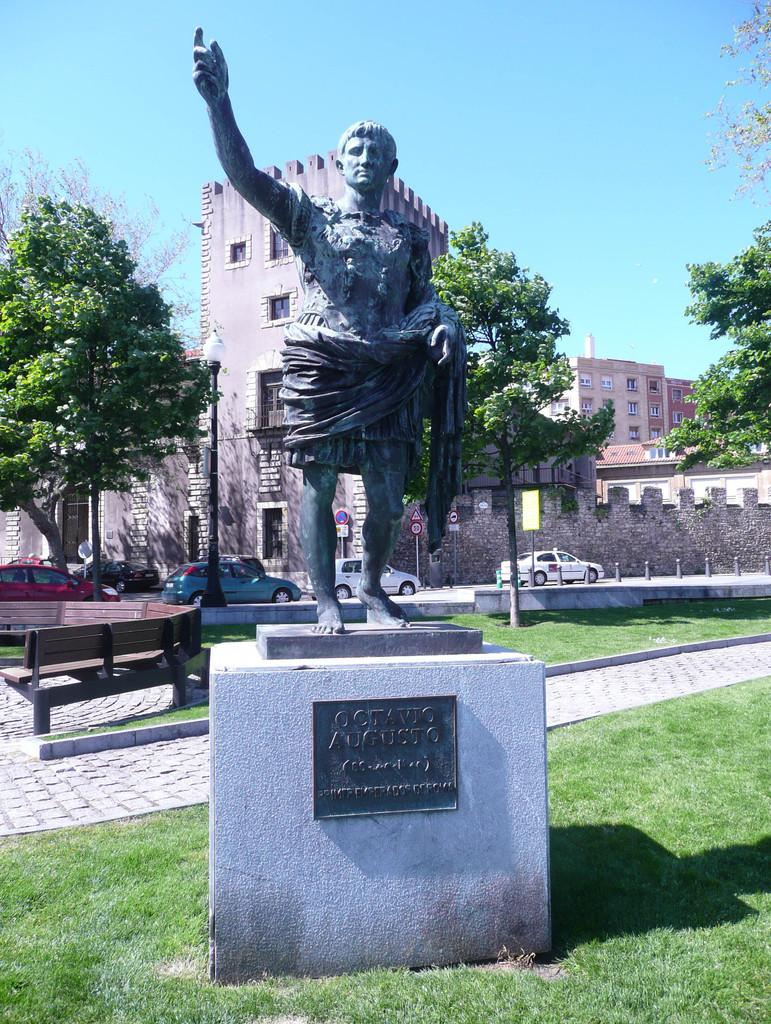What is the main subject in the center of the image? There is a statue in the center of the image. Where is the statue located? The statue is on the grass. What can be seen in the background of the image? In the background of the image, there are benches, trees, vehicles, roads, sign boards, and the sky. What type of game is being played on the statue in the image? There is no game being played on the statue in the image; it is a stationary statue. Who is the governor mentioned in the image? There is no mention of a governor in the image. 